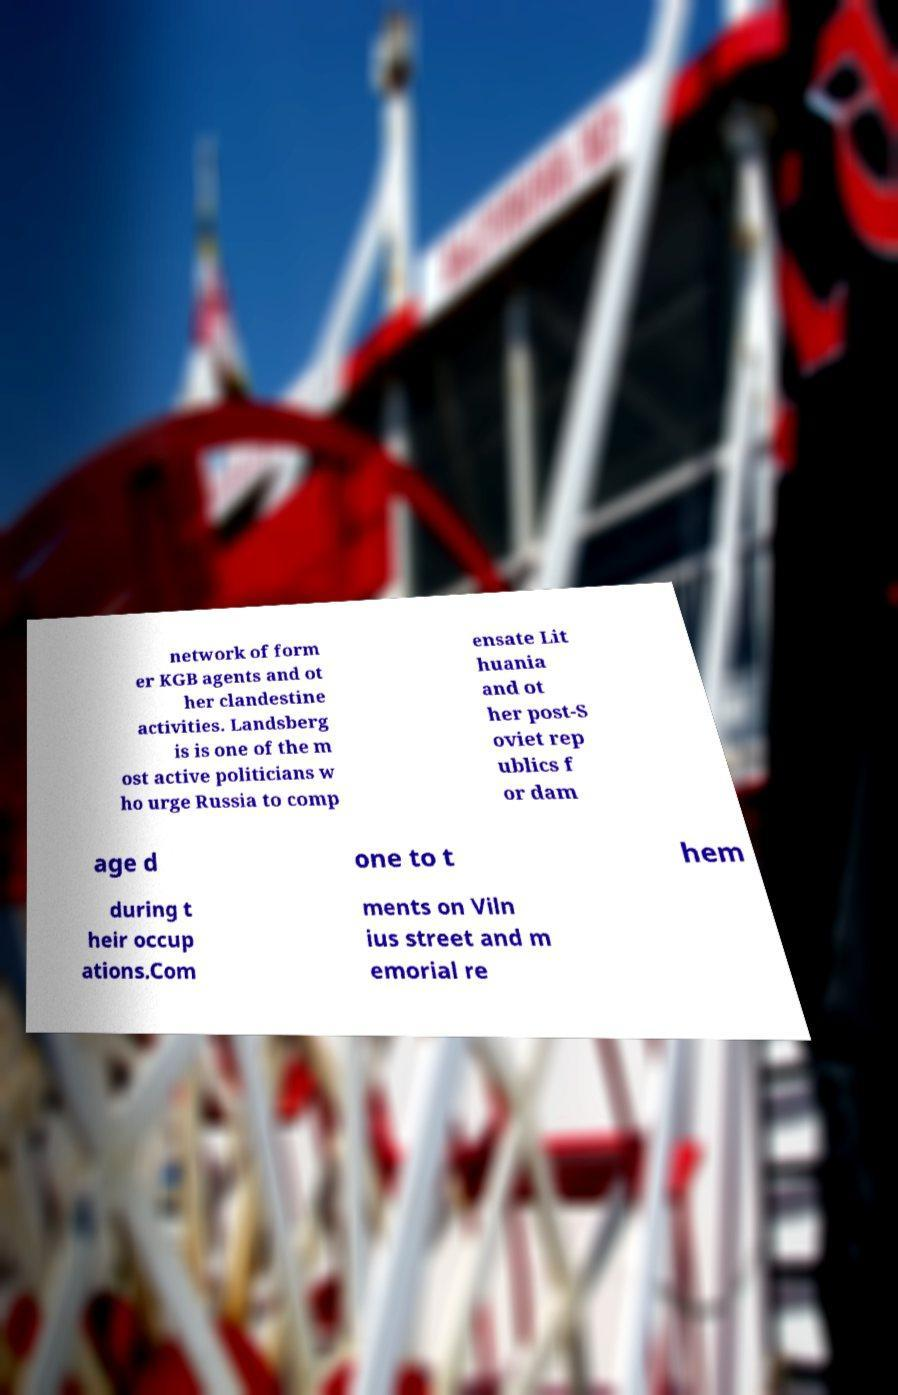Can you read and provide the text displayed in the image?This photo seems to have some interesting text. Can you extract and type it out for me? network of form er KGB agents and ot her clandestine activities. Landsberg is is one of the m ost active politicians w ho urge Russia to comp ensate Lit huania and ot her post-S oviet rep ublics f or dam age d one to t hem during t heir occup ations.Com ments on Viln ius street and m emorial re 